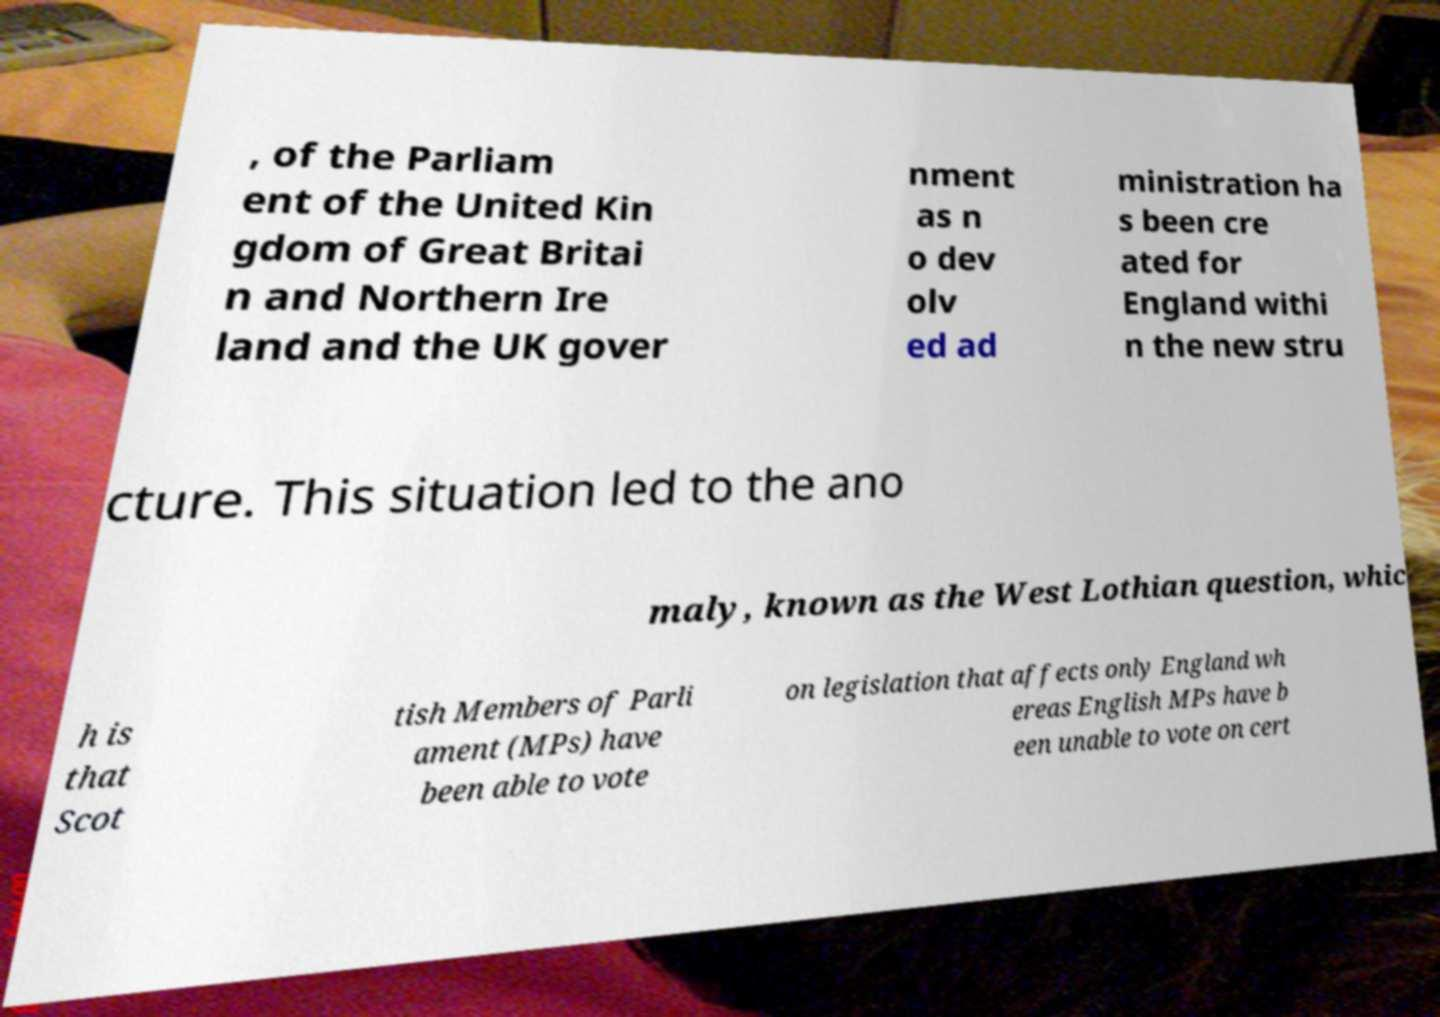Please read and relay the text visible in this image. What does it say? , of the Parliam ent of the United Kin gdom of Great Britai n and Northern Ire land and the UK gover nment as n o dev olv ed ad ministration ha s been cre ated for England withi n the new stru cture. This situation led to the ano maly, known as the West Lothian question, whic h is that Scot tish Members of Parli ament (MPs) have been able to vote on legislation that affects only England wh ereas English MPs have b een unable to vote on cert 